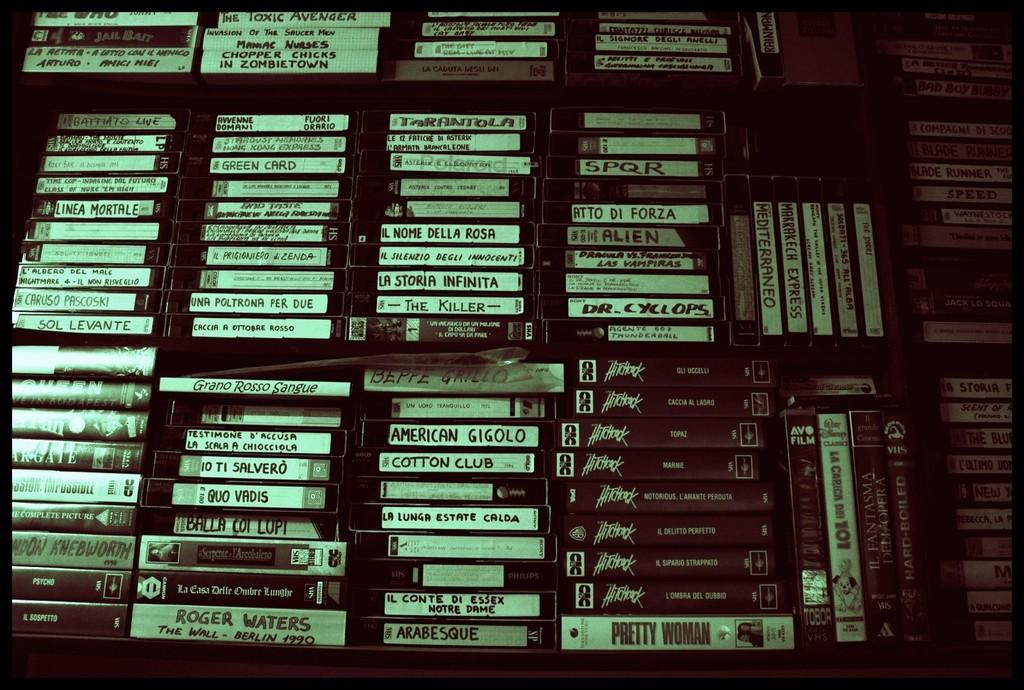<image>
Describe the image concisely. several video tapes stacked up on a shelf include Quo Vadis 